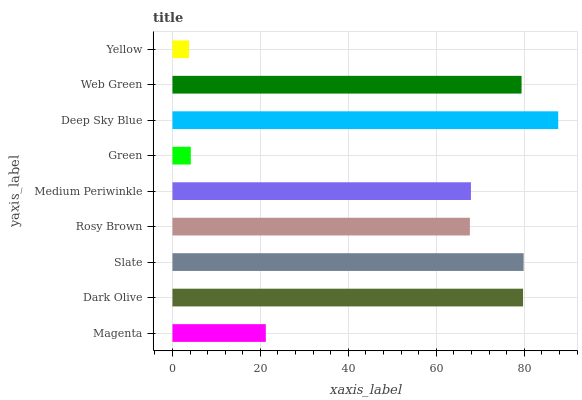Is Yellow the minimum?
Answer yes or no. Yes. Is Deep Sky Blue the maximum?
Answer yes or no. Yes. Is Dark Olive the minimum?
Answer yes or no. No. Is Dark Olive the maximum?
Answer yes or no. No. Is Dark Olive greater than Magenta?
Answer yes or no. Yes. Is Magenta less than Dark Olive?
Answer yes or no. Yes. Is Magenta greater than Dark Olive?
Answer yes or no. No. Is Dark Olive less than Magenta?
Answer yes or no. No. Is Medium Periwinkle the high median?
Answer yes or no. Yes. Is Medium Periwinkle the low median?
Answer yes or no. Yes. Is Yellow the high median?
Answer yes or no. No. Is Web Green the low median?
Answer yes or no. No. 